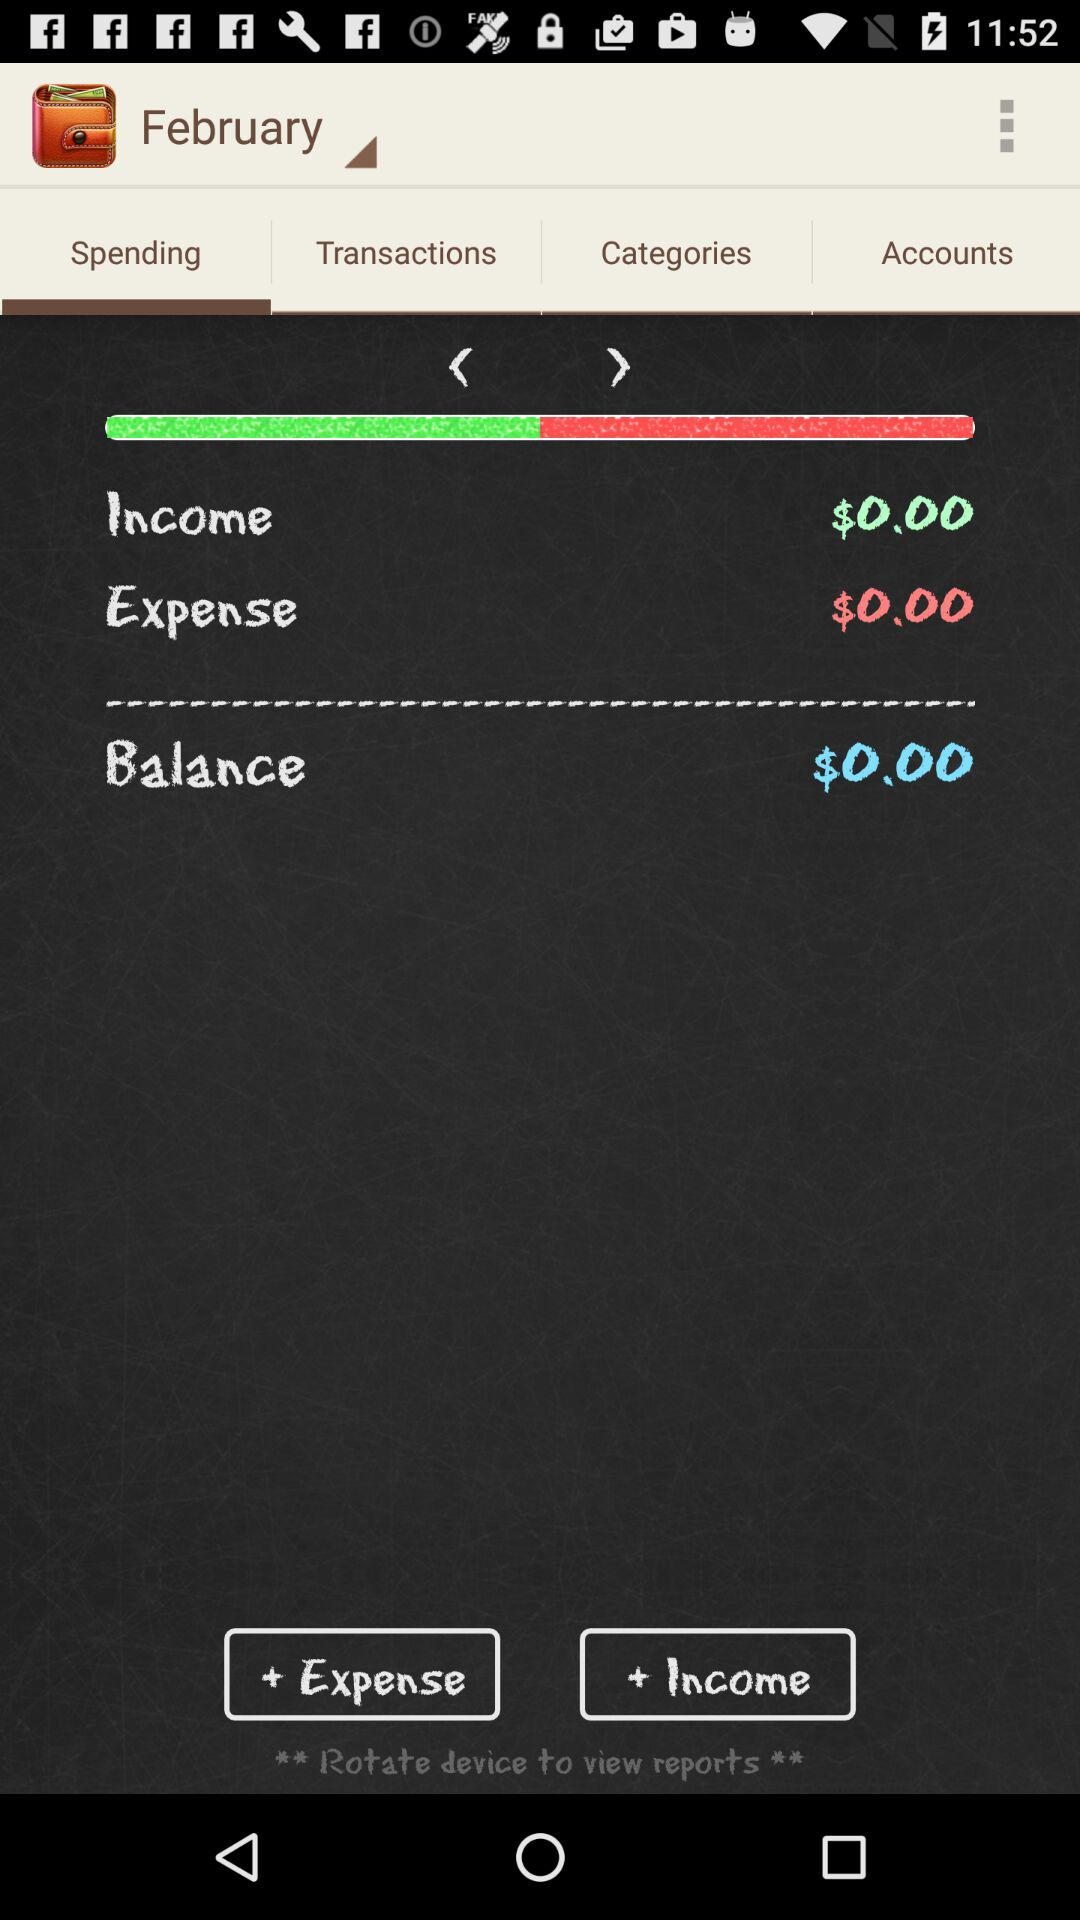What is the total amount of money spent and earned?
Answer the question using a single word or phrase. $0.00 